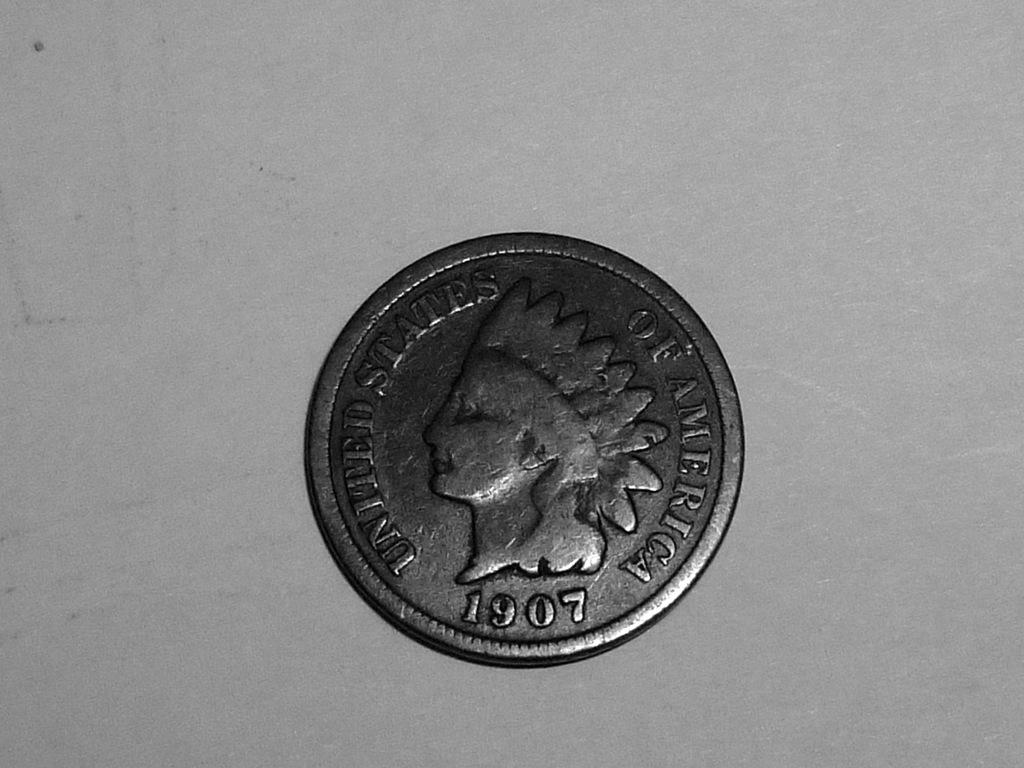Provide a one-sentence caption for the provided image. a coin that says 1907, united states of america on it. 